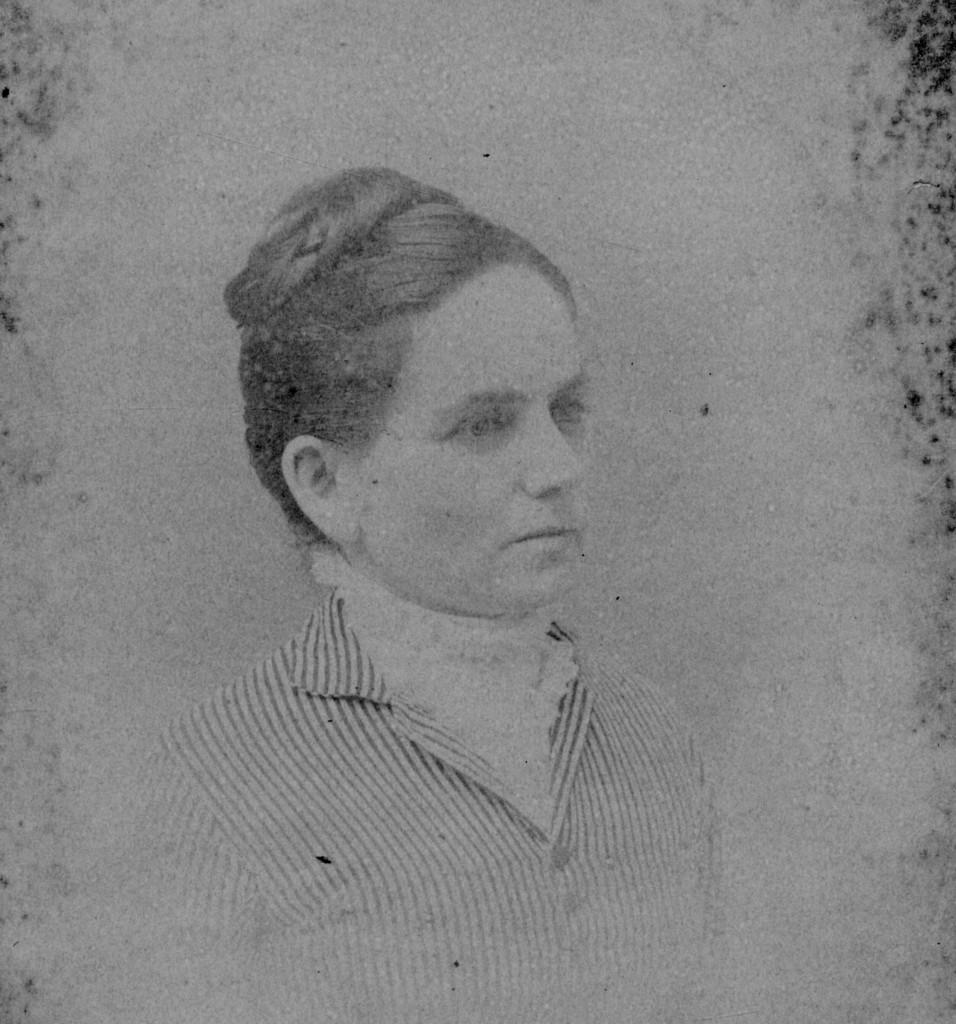What can be observed about the image itself? The image is edited. What is the main subject of the image? There is a picture of a woman in the image. What type of debt is the woman discussing in the image? There is no indication in the image that the woman is discussing any debt, as the image only shows a picture of a woman. How many letters are visible in the image? There are no letters visible in the image. What kind of bubble can be seen in the image? There is no bubble present in the image. 